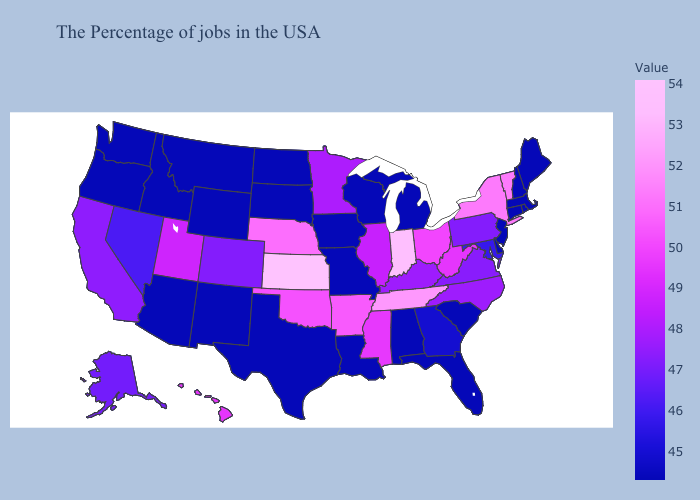Does Kansas have the highest value in the USA?
Keep it brief. Yes. Which states have the highest value in the USA?
Short answer required. Kansas. Among the states that border Florida , does Georgia have the lowest value?
Be succinct. No. Is the legend a continuous bar?
Keep it brief. Yes. Among the states that border Arkansas , does Missouri have the lowest value?
Be succinct. Yes. 